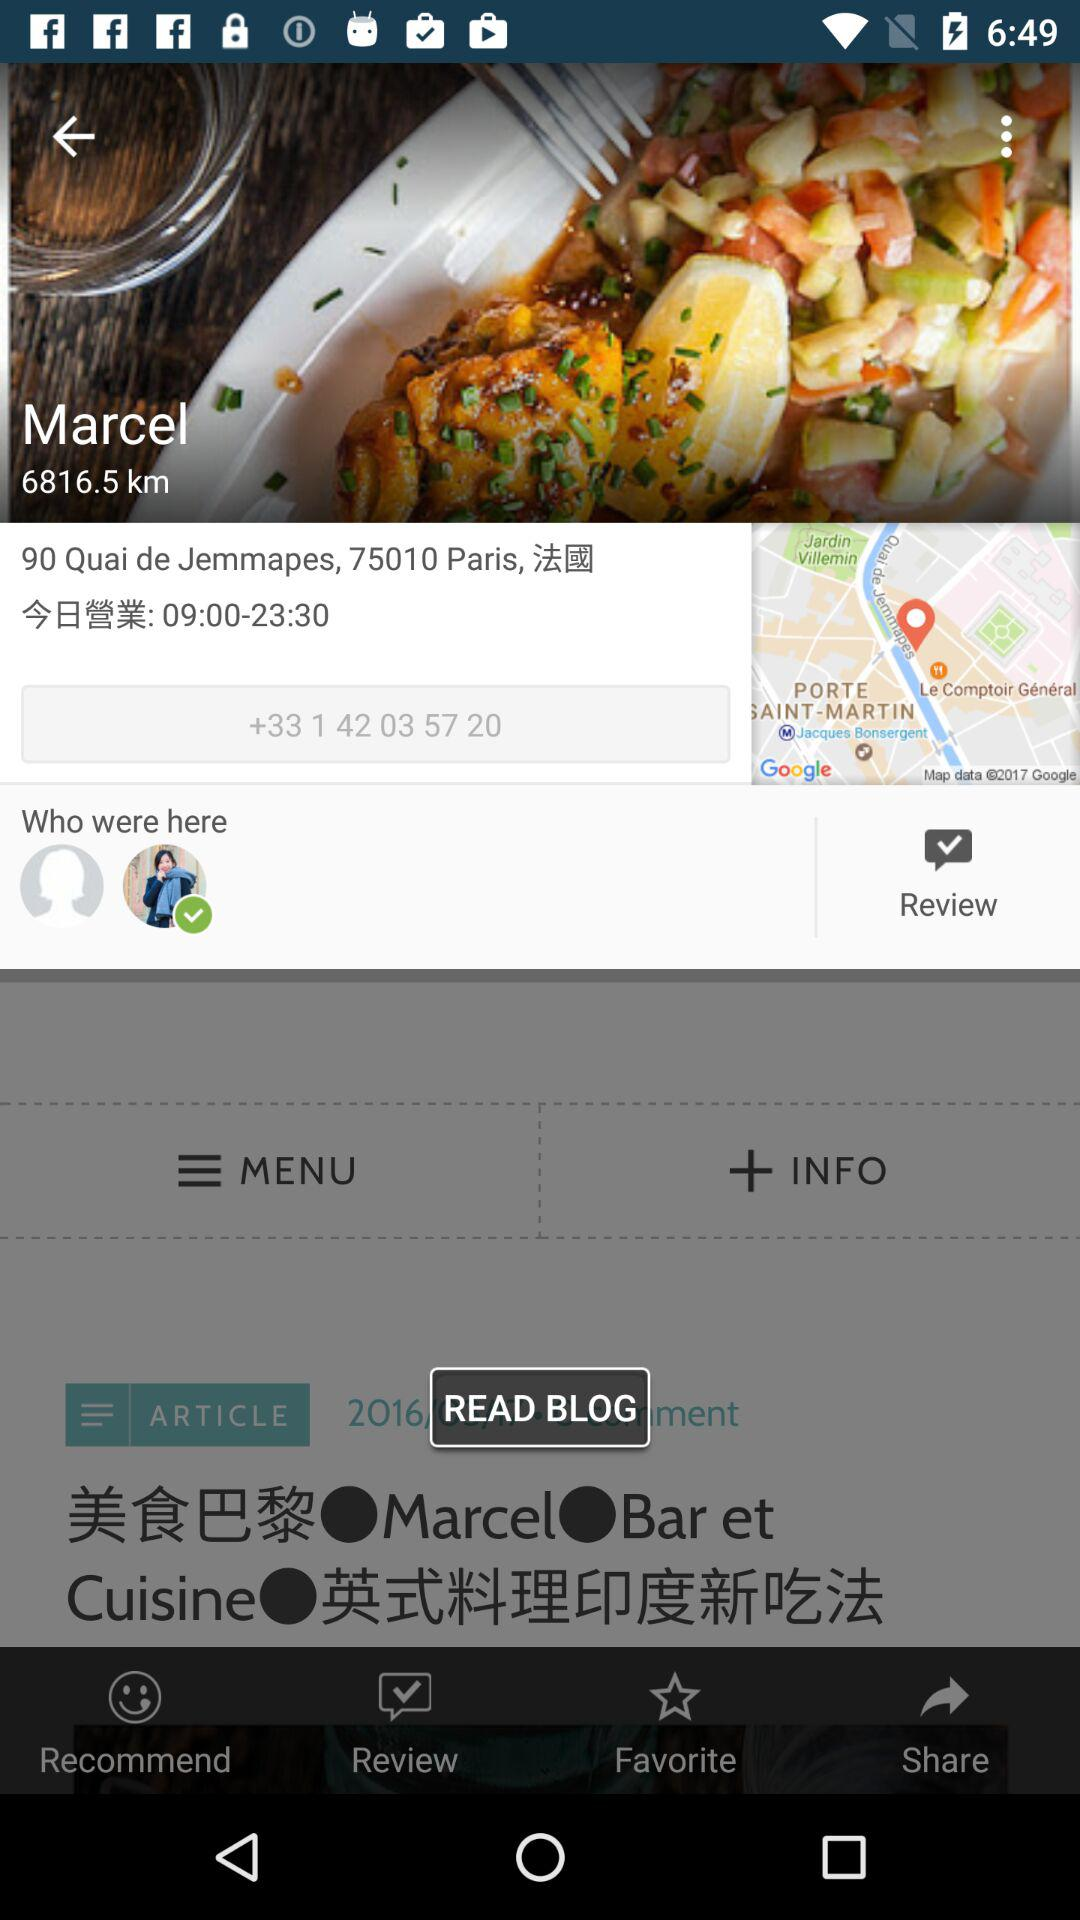What is the contact number? The contact number is +33 1 42 03 57 20. 